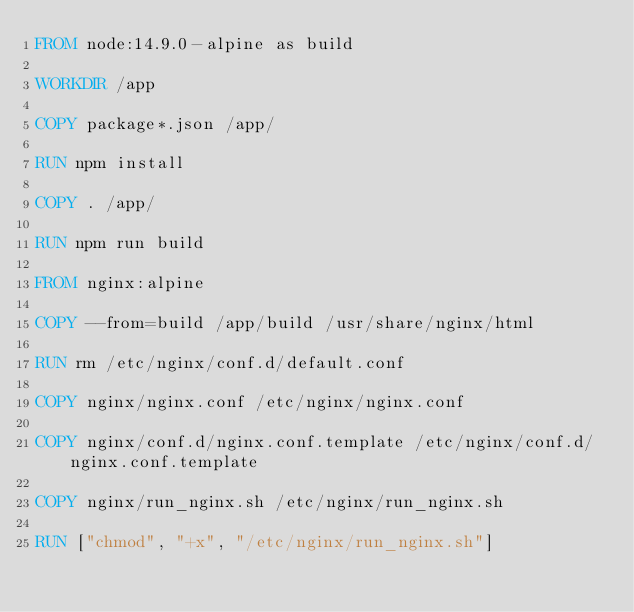<code> <loc_0><loc_0><loc_500><loc_500><_Dockerfile_>FROM node:14.9.0-alpine as build

WORKDIR /app

COPY package*.json /app/

RUN npm install

COPY . /app/

RUN npm run build

FROM nginx:alpine

COPY --from=build /app/build /usr/share/nginx/html

RUN rm /etc/nginx/conf.d/default.conf

COPY nginx/nginx.conf /etc/nginx/nginx.conf

COPY nginx/conf.d/nginx.conf.template /etc/nginx/conf.d/nginx.conf.template

COPY nginx/run_nginx.sh /etc/nginx/run_nginx.sh

RUN ["chmod", "+x", "/etc/nginx/run_nginx.sh"]</code> 